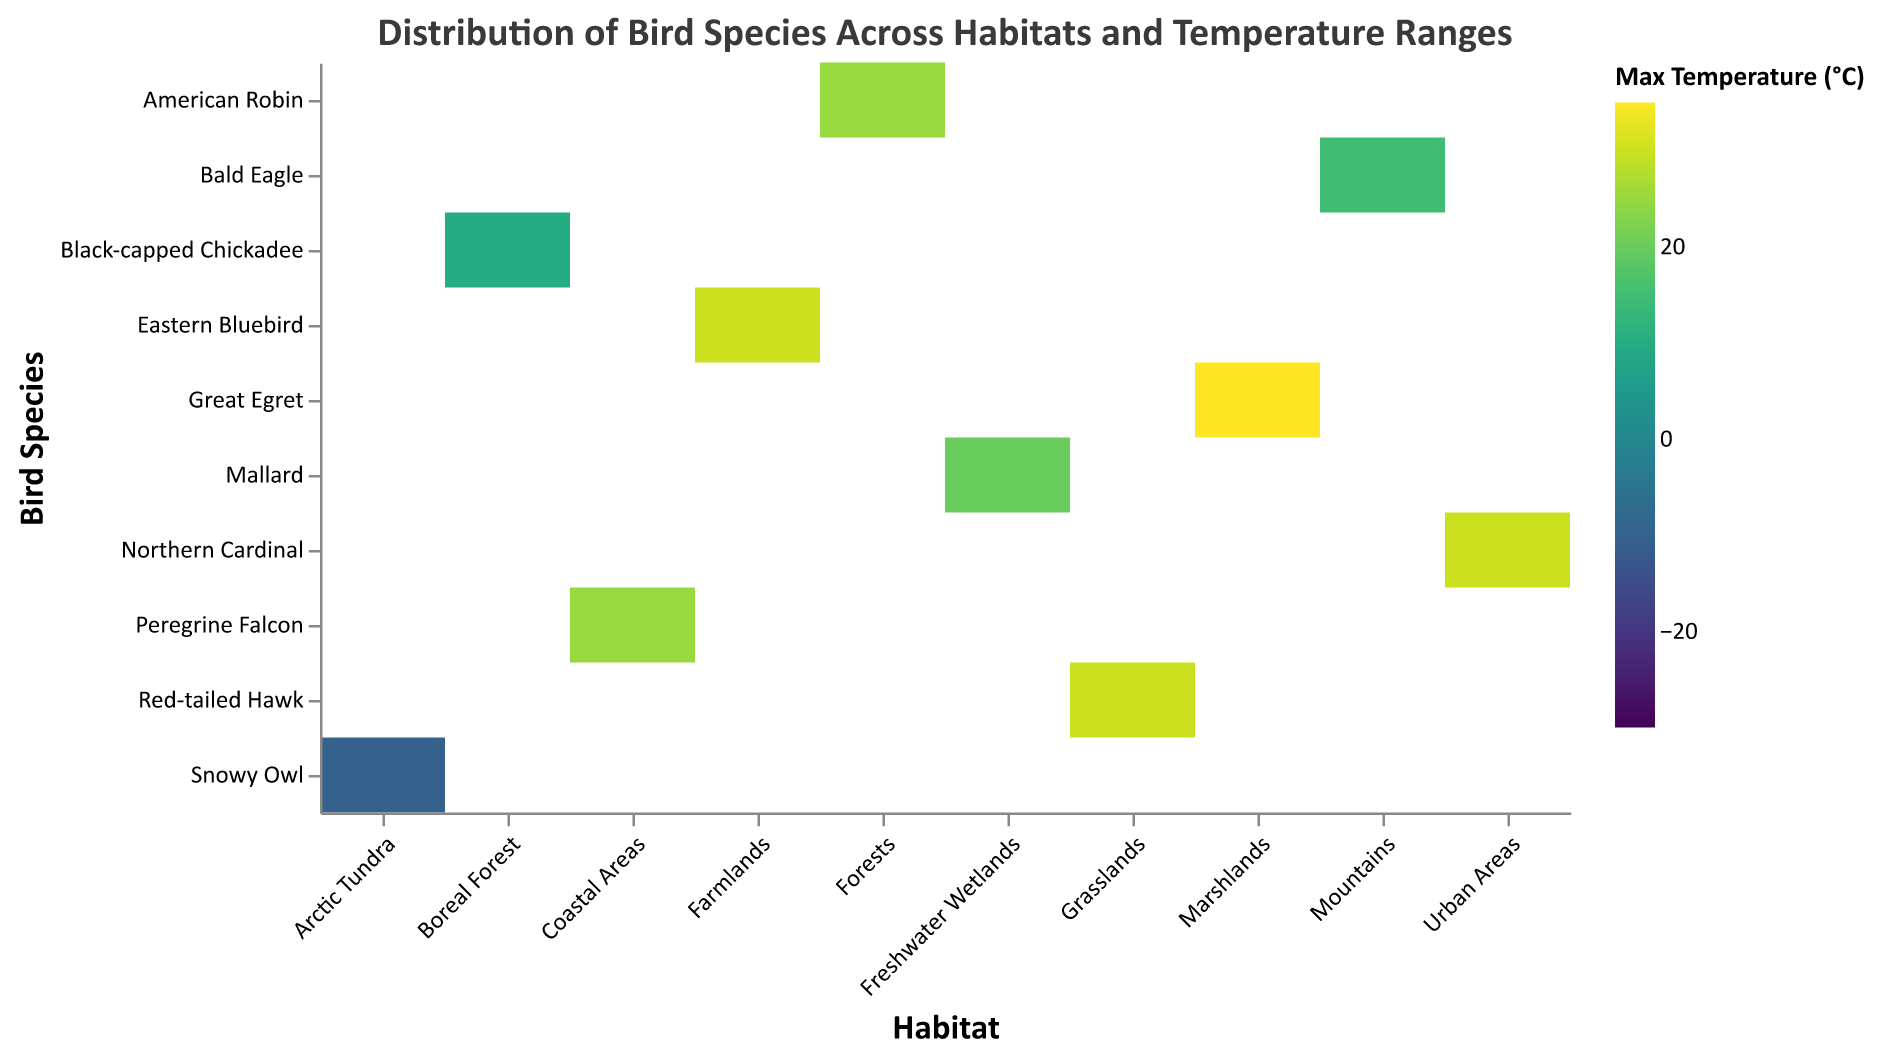What is the title of the heatmap? The title is typically located at the top of the heatmap and provides a summary of the data being presented. In this case, it reads "Distribution of Bird Species Across Habitats and Temperature Ranges."
Answer: Distribution of Bird Species Across Habitats and Temperature Ranges Which bird species can be found in the Arctic Tundra? By looking at the "Habitat" axis and spotting "Arctic Tundra", we can identify which bird species are associated with this habitat. On the "Species" axis, the corresponding species is "Snowy Owl."
Answer: Snowy Owl Which habitat has the highest maximum temperature recorded, and what is that temperature? By examining the color scale and identifying the habitat with the darkest color indicating the highest temperature, "Marshlands" appears to have the highest maximum temperature at 35°C.
Answer: Marshlands, 35°C What is the minimum temperature range for the Black-capped Chickadee? Find the "Black-capped Chickadee" on the "Species" axis and identify the corresponding minimum temperature value. The value is -20°C.
Answer: -20°C Which species have a maximum temperature range greater than 25°C? By comparing the maximum temperature values across the species, "Great Egret" and "Northern Cardinal" both have maximum temperature ranges exceeding 25°C.
Answer: Great Egret, Northern Cardinal What is the temperature range for the Bald Eagle? Look at the "Bald Eagle" entry and note both the minimum and maximum temperature values, which are -10°C and 15°C respectively.
Answer: -10°C to 15°C How many habitats have a bird species with a minimum temperature less than 0°C? Count the number of unique habitats where the minimum temperature is below 0°C for the bird species in those habitats. There are three: Mountains, Arctic Tundra, and Boreal Forest.
Answer: 3 Which bird species has the broadest temperature range, and what is that range? Calculate the temperature range (Max_Temperature - Min_Temperature) for each species. The "Great Egret" has the broadest range of 20°C (35°C - 15°C).
Answer: Great Egret, 20°C Which bird species live in Urban Areas, and what are their temperature ranges? Refer to the "Urban Areas" habitat and find the corresponding species and temperatures. The "Northern Cardinal" lives in Urban Areas with a temperature range of 15°C to 30°C.
Answer: Northern Cardinal, 15°C to 30°C Which species is found in Grasslands, and what is its maximum temperature range? Identify the species associated with "Grasslands" as the habitat and note its maximum temperature. The "Red-tailed Hawk" is found here, with a maximum temperature of 30°C.
Answer: Red-tailed Hawk, 30°C 